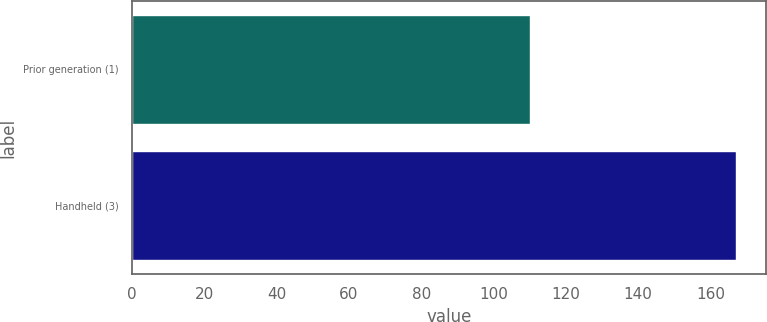Convert chart. <chart><loc_0><loc_0><loc_500><loc_500><bar_chart><fcel>Prior generation (1)<fcel>Handheld (3)<nl><fcel>110.1<fcel>167.1<nl></chart> 